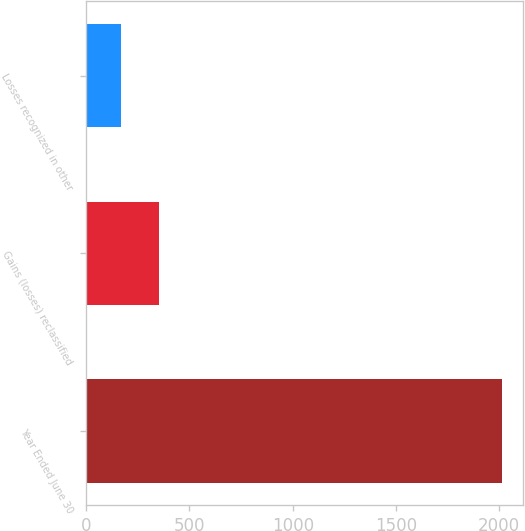Convert chart to OTSL. <chart><loc_0><loc_0><loc_500><loc_500><bar_chart><fcel>Year Ended June 30<fcel>Gains (losses) reclassified<fcel>Losses recognized in other<nl><fcel>2013<fcel>352.5<fcel>168<nl></chart> 